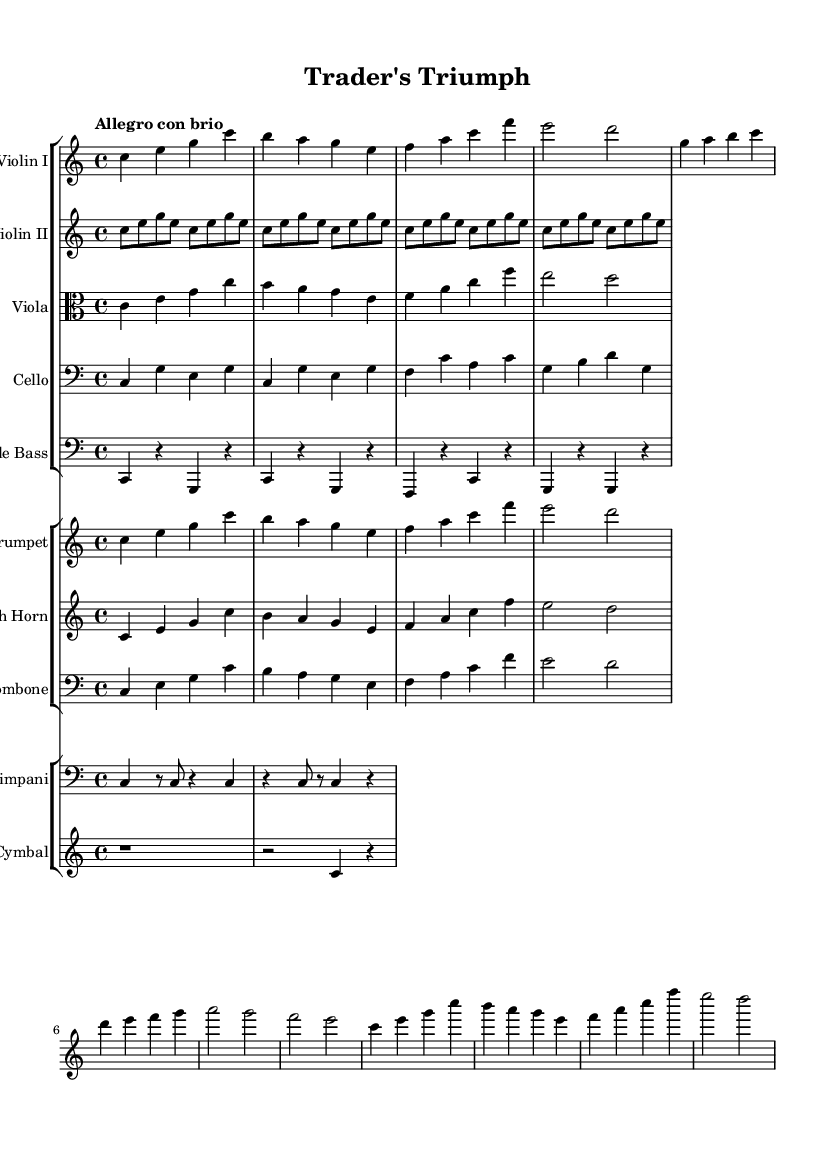What is the key signature of this music? The key signature is C major, which has no sharps or flats indicated in the staff.
Answer: C major What is the time signature of this piece? The time signature is found at the beginning of the score, which indicates 4 beats per measure.
Answer: 4/4 What is the tempo marking for this piece? The tempo marking "Allegro con brio" is specified at the beginning, indicating a lively and spirited tempo.
Answer: Allegro con brio Which instruments are used in the first group of the score? By examining the first StaffGroup, the instruments listed are Violin I, Violin II, Viola, Cello, and Double Bass.
Answer: Violin I, Violin II, Viola, Cello, Double Bass How many measures are there in the violin part? By counting the measures in the Violin I and Violin II parts, both contain the same number of repeated measures, totaling eight measures in this section.
Answer: Eight What is the role of the Timpani in this piece? The Timpani provide rhythmic support and accentuation through their particular note patterns, creating a strong foundation for the orchestration.
Answer: Rhythmic support Which instruments play the melody in this score? The melody is primarily carried by violin parts, specifically Violin I and supported by the other string instruments, while the brass also provide melodic accents.
Answer: Violin I 